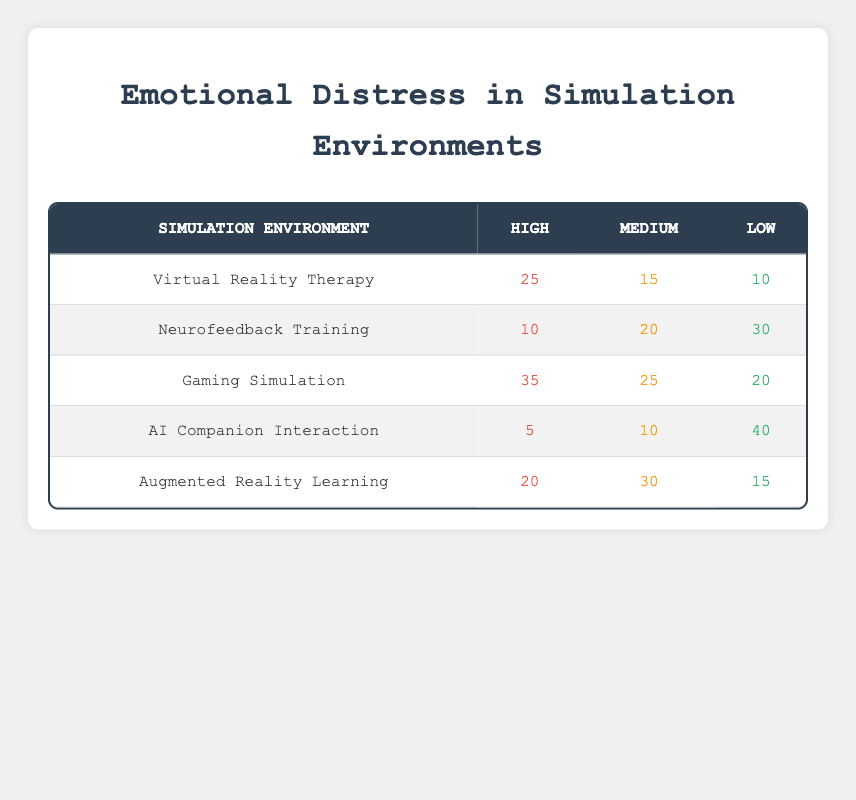What is the highest incidence of emotional distress recorded in any simulation environment? By examining the "High" column across all environments, I can see that the highest value is 35 from the "Gaming Simulation".
Answer: 35 Which simulation environment has the lowest overall incidence of emotional distress? To find the lowest overall, I sum the emotional distress incidences for each environment: Virtual Reality Therapy = 25 + 15 + 10 = 50, Neurofeedback Training = 10 + 20 + 30 = 60, Gaming Simulation = 35 + 25 + 20 = 80, AI Companion Interaction = 5 + 10 + 40 = 55, Augmented Reality Learning = 20 + 30 + 15 = 65. The lowest sum is from "AI Companion Interaction" with 55.
Answer: AI Companion Interaction Is the incidence of high emotional distress greater in "Gaming Simulation" than in "Virtual Reality Therapy"? Looking at the "High" column, "Gaming Simulation" has 35 while "Virtual Reality Therapy" has 25. Since 35 is greater than 25, the answer is yes.
Answer: Yes What is the average incidence of medium emotional distress across all simulation environments? I first add the "Medium" values: 15 + 20 + 25 + 10 + 30 = 100. There are 5 environments, so the average is 100 divided by 5, which is 20.
Answer: 20 Is there any simulation environment with "low" emotional distress incidence of 50 or more? Checking the "Low" column, the numbers are 10, 30, 20, 40, and 15, none of which meet or exceed 50. Therefore, the answer is no.
Answer: No Which environment has the highest incidence of medium emotional distress? Looking at the "Medium" column, the highest value is 30 from "Augmented Reality Learning".
Answer: Augmented Reality Learning What is the difference between the highest and lowest incidences of emotional distress in the "low" category? The highest is 40 (AI Companion Interaction) and the lowest is 10 (Virtual Reality Therapy). The difference is 40 minus 10, which equals 30.
Answer: 30 In which environment is the emotional distress incidence equally distributed across high, medium, and low categories? None of the environments show equal incidences across high, medium, and low because the values vary significantly in each environment.
Answer: No 